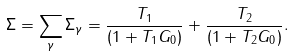Convert formula to latex. <formula><loc_0><loc_0><loc_500><loc_500>\Sigma = \sum _ { \gamma } \Sigma _ { \gamma } = \frac { T _ { 1 } } { ( 1 + T _ { 1 } G _ { 0 } ) } + \frac { T _ { 2 } } { ( 1 + T _ { 2 } G _ { 0 } ) } .</formula> 